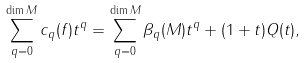<formula> <loc_0><loc_0><loc_500><loc_500>\sum _ { q = 0 } ^ { \dim M } c _ { q } ( f ) t ^ { q } = \sum _ { q = 0 } ^ { \dim M } \beta _ { q } ( M ) t ^ { q } + ( 1 + t ) Q ( t ) ,</formula> 